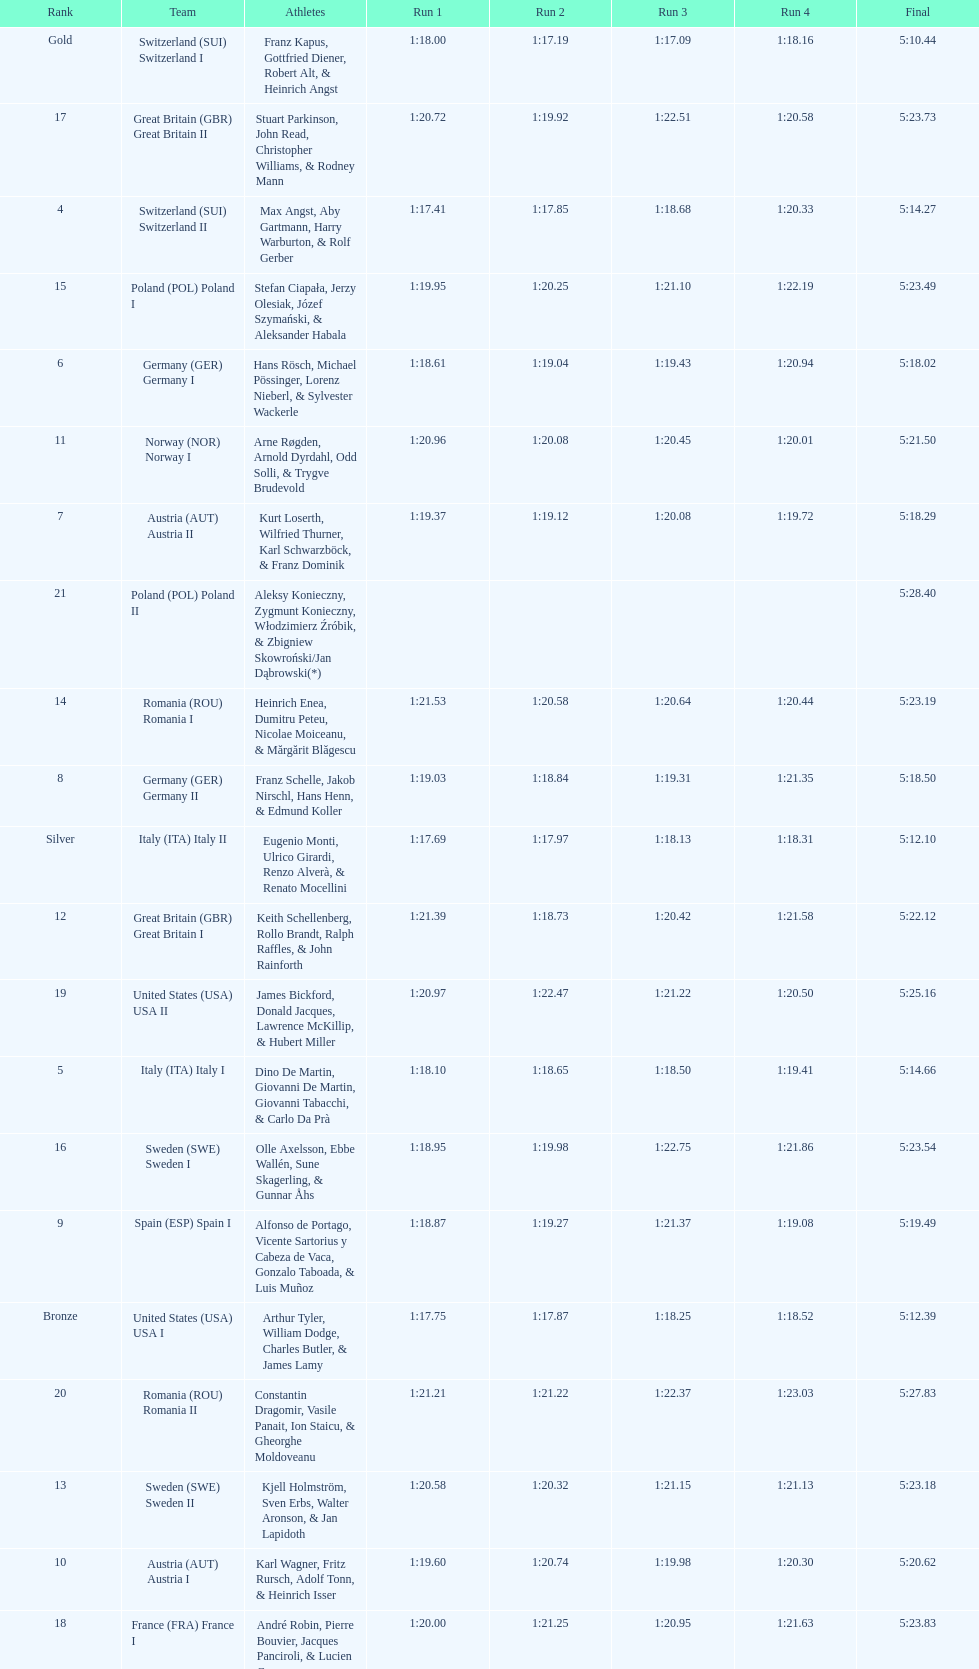Which team had the most time? Poland. 